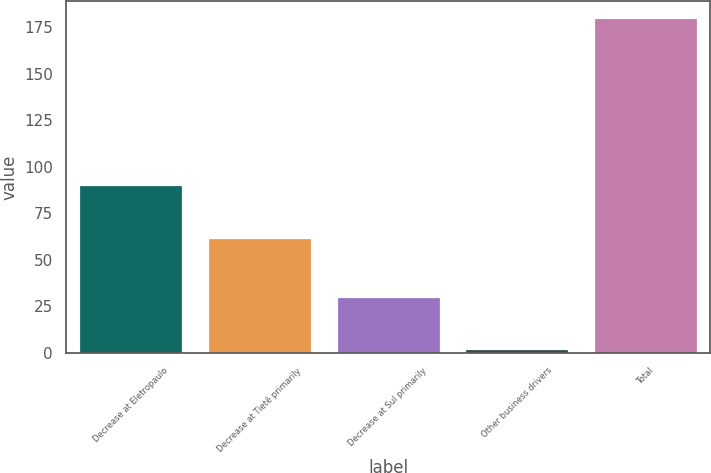Convert chart to OTSL. <chart><loc_0><loc_0><loc_500><loc_500><bar_chart><fcel>Decrease at Eletropaulo<fcel>Decrease at Tietê primarily<fcel>Decrease at Sul primarily<fcel>Other business drivers<fcel>Total<nl><fcel>90<fcel>62<fcel>30<fcel>2<fcel>180<nl></chart> 